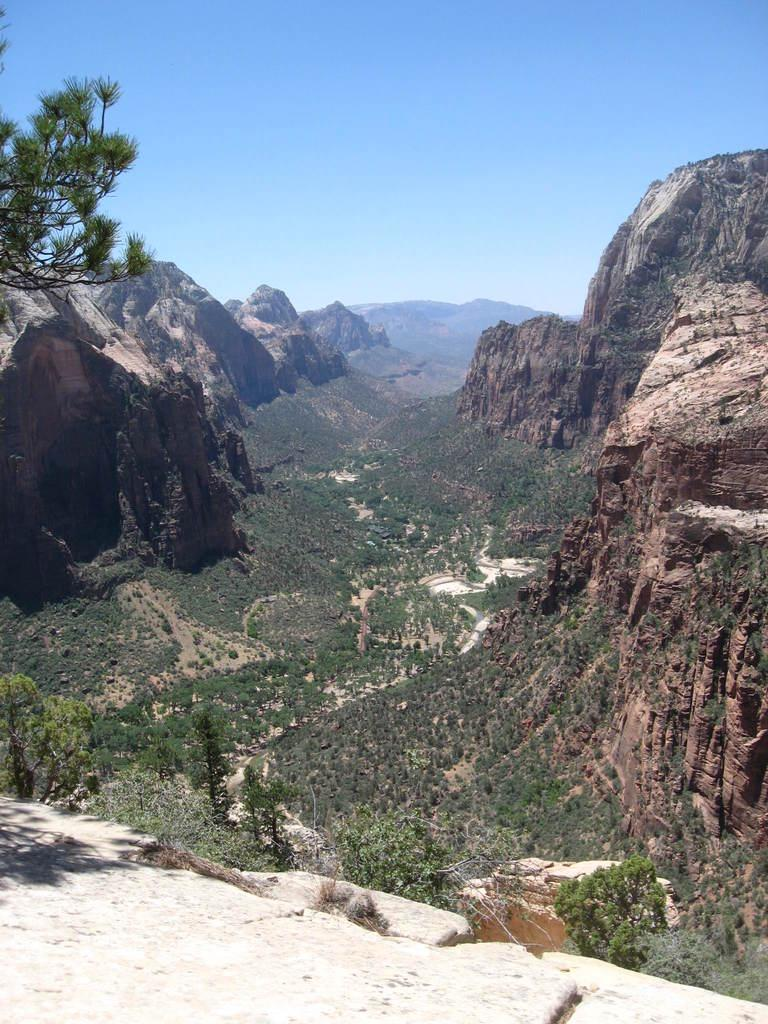What type of natural landscape is depicted in the image? The image features mountains, trees, and grass, which are all elements of a natural landscape. Can you describe the vegetation in the image? There are trees and grass visible in the image. What is visible in the sky in the image? The sky is visible in the image. What type of voice can be heard coming from the trees in the image? There is no voice present in the image, as it is a still image of a natural landscape. Is there a maid visible in the image? There is no maid present in the image; it features a natural landscape with mountains, trees, grass, and the sky. 